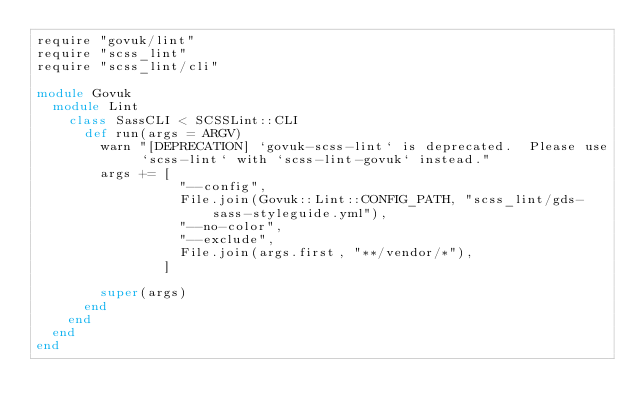<code> <loc_0><loc_0><loc_500><loc_500><_Ruby_>require "govuk/lint"
require "scss_lint"
require "scss_lint/cli"

module Govuk
  module Lint
    class SassCLI < SCSSLint::CLI
      def run(args = ARGV)
        warn "[DEPRECATION] `govuk-scss-lint` is deprecated.  Please use `scss-lint` with `scss-lint-govuk` instead."
        args += [
                  "--config",
                  File.join(Govuk::Lint::CONFIG_PATH, "scss_lint/gds-sass-styleguide.yml"),
                  "--no-color",
                  "--exclude",
                  File.join(args.first, "**/vendor/*"),
                ]

        super(args)
      end
    end
  end
end
</code> 